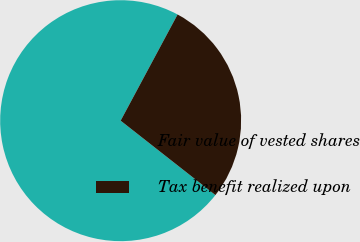Convert chart to OTSL. <chart><loc_0><loc_0><loc_500><loc_500><pie_chart><fcel>Fair value of vested shares<fcel>Tax benefit realized upon<nl><fcel>72.24%<fcel>27.76%<nl></chart> 